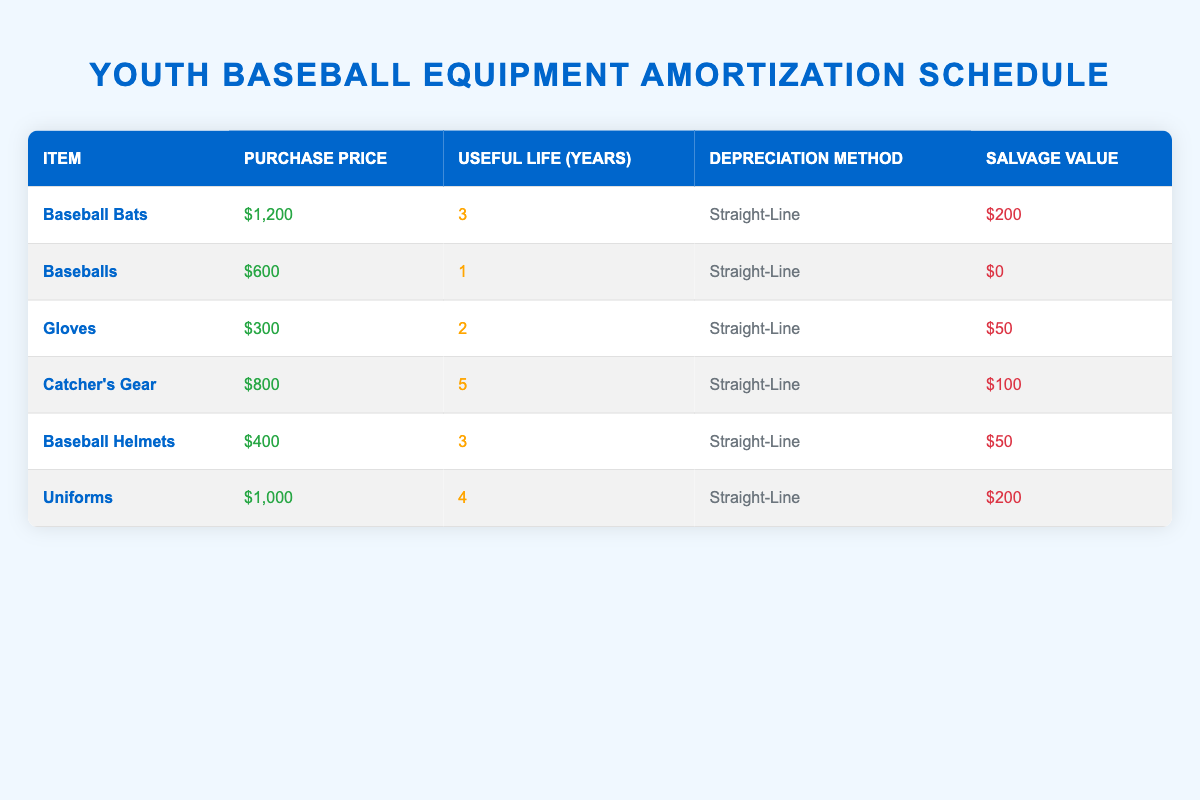What is the purchase price of the Baseball Helmets? The purchase price is provided in the table under the corresponding item. For Baseball Helmets, the purchase price is listed as $400.
Answer: $400 How many years of useful life do Gloves have? The useful life of Gloves is specified in the table next to the item. It shows that Gloves have a useful life of 2 years.
Answer: 2 What is the total purchase price of all the equipment? To find the total purchase price, sum the purchase prices of all items: $1200 + $600 + $300 + $800 + $400 + $1000 = $4000.
Answer: $4000 Do all items have a salvage value greater than zero? To determine this, check the salvage values in the table. Baseballs have a salvage value of $0, thus not all items have a salvage value greater than zero.
Answer: No Which item has the longest useful life? Review the useful life of each item in the table: Baseball Bats (3 years), Baseballs (1 year), Gloves (2 years), Catcher's Gear (5 years), Baseball Helmets (3 years), and Uniforms (4 years). The longest useful life is 5 years for Catcher's Gear.
Answer: Catcher's Gear What is the average salvage value of the equipment? Calculate the average salvage value by adding all salvage values: $200 + $0 + $50 + $100 + $50 + $200 = $600. There are 6 items, so the average is $600/6 = $100.
Answer: $100 How much total depreciable cost is there for Baseball Bats? The depreciable cost is calculated as the purchase price minus the salvage value. For Baseball Bats: $1200 - $200 = $1000.
Answer: $1000 Is the depreciation method the same for all items? Check the depreciation method column for each item. All items list "Straight-Line" as their method, indicating they are the same.
Answer: Yes What is the difference in purchase prices between the most expensive and least expensive items? Identify the most expensive item (Baseball Bats at $1200) and the least expensive (Baseballs at $600). The difference is $1200 - $600 = $600.
Answer: $600 